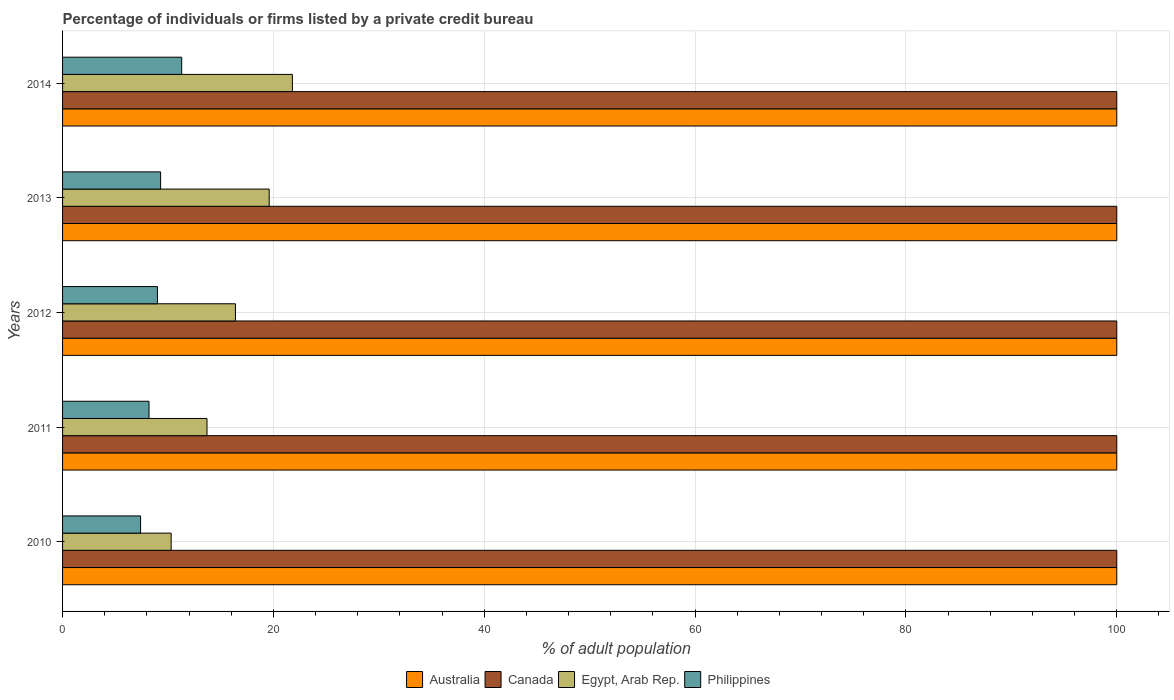How many groups of bars are there?
Offer a terse response. 5. Are the number of bars on each tick of the Y-axis equal?
Offer a terse response. Yes. How many bars are there on the 1st tick from the top?
Offer a terse response. 4. What is the label of the 5th group of bars from the top?
Keep it short and to the point. 2010. What is the percentage of population listed by a private credit bureau in Canada in 2010?
Give a very brief answer. 100. Across all years, what is the maximum percentage of population listed by a private credit bureau in Canada?
Make the answer very short. 100. What is the total percentage of population listed by a private credit bureau in Philippines in the graph?
Provide a short and direct response. 45.2. What is the difference between the percentage of population listed by a private credit bureau in Canada in 2010 and that in 2014?
Make the answer very short. 0. What is the difference between the percentage of population listed by a private credit bureau in Canada in 2011 and the percentage of population listed by a private credit bureau in Australia in 2012?
Ensure brevity in your answer.  0. In the year 2011, what is the difference between the percentage of population listed by a private credit bureau in Australia and percentage of population listed by a private credit bureau in Philippines?
Your answer should be compact. 91.8. In how many years, is the percentage of population listed by a private credit bureau in Egypt, Arab Rep. greater than 84 %?
Keep it short and to the point. 0. What is the ratio of the percentage of population listed by a private credit bureau in Philippines in 2012 to that in 2013?
Give a very brief answer. 0.97. What is the difference between the highest and the second highest percentage of population listed by a private credit bureau in Australia?
Give a very brief answer. 0. What is the difference between the highest and the lowest percentage of population listed by a private credit bureau in Egypt, Arab Rep.?
Make the answer very short. 11.5. In how many years, is the percentage of population listed by a private credit bureau in Canada greater than the average percentage of population listed by a private credit bureau in Canada taken over all years?
Provide a succinct answer. 0. Is the sum of the percentage of population listed by a private credit bureau in Australia in 2011 and 2014 greater than the maximum percentage of population listed by a private credit bureau in Egypt, Arab Rep. across all years?
Keep it short and to the point. Yes. Is it the case that in every year, the sum of the percentage of population listed by a private credit bureau in Canada and percentage of population listed by a private credit bureau in Egypt, Arab Rep. is greater than the sum of percentage of population listed by a private credit bureau in Philippines and percentage of population listed by a private credit bureau in Australia?
Offer a very short reply. Yes. What does the 3rd bar from the top in 2013 represents?
Your answer should be compact. Canada. What does the 2nd bar from the bottom in 2012 represents?
Make the answer very short. Canada. Is it the case that in every year, the sum of the percentage of population listed by a private credit bureau in Egypt, Arab Rep. and percentage of population listed by a private credit bureau in Canada is greater than the percentage of population listed by a private credit bureau in Australia?
Ensure brevity in your answer.  Yes. How many bars are there?
Keep it short and to the point. 20. Are all the bars in the graph horizontal?
Provide a succinct answer. Yes. What is the difference between two consecutive major ticks on the X-axis?
Offer a very short reply. 20. Does the graph contain grids?
Your answer should be very brief. Yes. What is the title of the graph?
Provide a succinct answer. Percentage of individuals or firms listed by a private credit bureau. What is the label or title of the X-axis?
Make the answer very short. % of adult population. What is the label or title of the Y-axis?
Keep it short and to the point. Years. What is the % of adult population of Australia in 2010?
Give a very brief answer. 100. What is the % of adult population of Canada in 2010?
Your response must be concise. 100. What is the % of adult population in Australia in 2011?
Make the answer very short. 100. What is the % of adult population of Canada in 2011?
Your answer should be very brief. 100. What is the % of adult population in Philippines in 2011?
Keep it short and to the point. 8.2. What is the % of adult population in Australia in 2012?
Keep it short and to the point. 100. What is the % of adult population in Australia in 2013?
Offer a terse response. 100. What is the % of adult population of Canada in 2013?
Offer a very short reply. 100. What is the % of adult population of Egypt, Arab Rep. in 2013?
Your answer should be compact. 19.6. What is the % of adult population in Egypt, Arab Rep. in 2014?
Your response must be concise. 21.8. Across all years, what is the maximum % of adult population in Canada?
Make the answer very short. 100. Across all years, what is the maximum % of adult population in Egypt, Arab Rep.?
Ensure brevity in your answer.  21.8. Across all years, what is the minimum % of adult population of Egypt, Arab Rep.?
Your answer should be very brief. 10.3. What is the total % of adult population of Australia in the graph?
Give a very brief answer. 500. What is the total % of adult population of Canada in the graph?
Make the answer very short. 500. What is the total % of adult population of Egypt, Arab Rep. in the graph?
Your answer should be very brief. 81.8. What is the total % of adult population of Philippines in the graph?
Make the answer very short. 45.2. What is the difference between the % of adult population of Australia in 2010 and that in 2011?
Your answer should be very brief. 0. What is the difference between the % of adult population of Australia in 2010 and that in 2012?
Provide a short and direct response. 0. What is the difference between the % of adult population of Egypt, Arab Rep. in 2010 and that in 2012?
Make the answer very short. -6.1. What is the difference between the % of adult population in Philippines in 2010 and that in 2012?
Keep it short and to the point. -1.6. What is the difference between the % of adult population of Egypt, Arab Rep. in 2010 and that in 2013?
Make the answer very short. -9.3. What is the difference between the % of adult population in Philippines in 2010 and that in 2013?
Your answer should be very brief. -1.9. What is the difference between the % of adult population in Australia in 2010 and that in 2014?
Provide a short and direct response. 0. What is the difference between the % of adult population in Australia in 2011 and that in 2012?
Your answer should be compact. 0. What is the difference between the % of adult population of Canada in 2011 and that in 2012?
Provide a short and direct response. 0. What is the difference between the % of adult population in Philippines in 2011 and that in 2012?
Ensure brevity in your answer.  -0.8. What is the difference between the % of adult population in Canada in 2011 and that in 2013?
Your answer should be compact. 0. What is the difference between the % of adult population of Egypt, Arab Rep. in 2011 and that in 2013?
Your response must be concise. -5.9. What is the difference between the % of adult population in Philippines in 2011 and that in 2013?
Your answer should be very brief. -1.1. What is the difference between the % of adult population of Australia in 2011 and that in 2014?
Give a very brief answer. 0. What is the difference between the % of adult population of Egypt, Arab Rep. in 2011 and that in 2014?
Ensure brevity in your answer.  -8.1. What is the difference between the % of adult population in Australia in 2012 and that in 2013?
Make the answer very short. 0. What is the difference between the % of adult population of Philippines in 2012 and that in 2013?
Your answer should be compact. -0.3. What is the difference between the % of adult population in Australia in 2012 and that in 2014?
Keep it short and to the point. 0. What is the difference between the % of adult population of Canada in 2012 and that in 2014?
Your answer should be compact. 0. What is the difference between the % of adult population of Egypt, Arab Rep. in 2012 and that in 2014?
Your answer should be compact. -5.4. What is the difference between the % of adult population of Egypt, Arab Rep. in 2013 and that in 2014?
Provide a succinct answer. -2.2. What is the difference between the % of adult population of Australia in 2010 and the % of adult population of Egypt, Arab Rep. in 2011?
Offer a terse response. 86.3. What is the difference between the % of adult population in Australia in 2010 and the % of adult population in Philippines in 2011?
Give a very brief answer. 91.8. What is the difference between the % of adult population of Canada in 2010 and the % of adult population of Egypt, Arab Rep. in 2011?
Your answer should be very brief. 86.3. What is the difference between the % of adult population in Canada in 2010 and the % of adult population in Philippines in 2011?
Your response must be concise. 91.8. What is the difference between the % of adult population in Australia in 2010 and the % of adult population in Canada in 2012?
Provide a succinct answer. 0. What is the difference between the % of adult population of Australia in 2010 and the % of adult population of Egypt, Arab Rep. in 2012?
Offer a very short reply. 83.6. What is the difference between the % of adult population of Australia in 2010 and the % of adult population of Philippines in 2012?
Provide a short and direct response. 91. What is the difference between the % of adult population in Canada in 2010 and the % of adult population in Egypt, Arab Rep. in 2012?
Ensure brevity in your answer.  83.6. What is the difference between the % of adult population in Canada in 2010 and the % of adult population in Philippines in 2012?
Your response must be concise. 91. What is the difference between the % of adult population of Australia in 2010 and the % of adult population of Canada in 2013?
Ensure brevity in your answer.  0. What is the difference between the % of adult population of Australia in 2010 and the % of adult population of Egypt, Arab Rep. in 2013?
Provide a succinct answer. 80.4. What is the difference between the % of adult population in Australia in 2010 and the % of adult population in Philippines in 2013?
Your answer should be compact. 90.7. What is the difference between the % of adult population of Canada in 2010 and the % of adult population of Egypt, Arab Rep. in 2013?
Keep it short and to the point. 80.4. What is the difference between the % of adult population in Canada in 2010 and the % of adult population in Philippines in 2013?
Give a very brief answer. 90.7. What is the difference between the % of adult population of Australia in 2010 and the % of adult population of Canada in 2014?
Ensure brevity in your answer.  0. What is the difference between the % of adult population of Australia in 2010 and the % of adult population of Egypt, Arab Rep. in 2014?
Provide a succinct answer. 78.2. What is the difference between the % of adult population of Australia in 2010 and the % of adult population of Philippines in 2014?
Your answer should be compact. 88.7. What is the difference between the % of adult population of Canada in 2010 and the % of adult population of Egypt, Arab Rep. in 2014?
Offer a very short reply. 78.2. What is the difference between the % of adult population of Canada in 2010 and the % of adult population of Philippines in 2014?
Your response must be concise. 88.7. What is the difference between the % of adult population in Australia in 2011 and the % of adult population in Egypt, Arab Rep. in 2012?
Ensure brevity in your answer.  83.6. What is the difference between the % of adult population of Australia in 2011 and the % of adult population of Philippines in 2012?
Ensure brevity in your answer.  91. What is the difference between the % of adult population in Canada in 2011 and the % of adult population in Egypt, Arab Rep. in 2012?
Keep it short and to the point. 83.6. What is the difference between the % of adult population of Canada in 2011 and the % of adult population of Philippines in 2012?
Ensure brevity in your answer.  91. What is the difference between the % of adult population in Australia in 2011 and the % of adult population in Canada in 2013?
Provide a short and direct response. 0. What is the difference between the % of adult population of Australia in 2011 and the % of adult population of Egypt, Arab Rep. in 2013?
Make the answer very short. 80.4. What is the difference between the % of adult population in Australia in 2011 and the % of adult population in Philippines in 2013?
Keep it short and to the point. 90.7. What is the difference between the % of adult population of Canada in 2011 and the % of adult population of Egypt, Arab Rep. in 2013?
Make the answer very short. 80.4. What is the difference between the % of adult population of Canada in 2011 and the % of adult population of Philippines in 2013?
Ensure brevity in your answer.  90.7. What is the difference between the % of adult population in Australia in 2011 and the % of adult population in Canada in 2014?
Make the answer very short. 0. What is the difference between the % of adult population of Australia in 2011 and the % of adult population of Egypt, Arab Rep. in 2014?
Your answer should be very brief. 78.2. What is the difference between the % of adult population of Australia in 2011 and the % of adult population of Philippines in 2014?
Offer a terse response. 88.7. What is the difference between the % of adult population in Canada in 2011 and the % of adult population in Egypt, Arab Rep. in 2014?
Give a very brief answer. 78.2. What is the difference between the % of adult population of Canada in 2011 and the % of adult population of Philippines in 2014?
Ensure brevity in your answer.  88.7. What is the difference between the % of adult population in Egypt, Arab Rep. in 2011 and the % of adult population in Philippines in 2014?
Ensure brevity in your answer.  2.4. What is the difference between the % of adult population in Australia in 2012 and the % of adult population in Canada in 2013?
Make the answer very short. 0. What is the difference between the % of adult population of Australia in 2012 and the % of adult population of Egypt, Arab Rep. in 2013?
Your response must be concise. 80.4. What is the difference between the % of adult population in Australia in 2012 and the % of adult population in Philippines in 2013?
Make the answer very short. 90.7. What is the difference between the % of adult population of Canada in 2012 and the % of adult population of Egypt, Arab Rep. in 2013?
Your response must be concise. 80.4. What is the difference between the % of adult population in Canada in 2012 and the % of adult population in Philippines in 2013?
Offer a terse response. 90.7. What is the difference between the % of adult population in Egypt, Arab Rep. in 2012 and the % of adult population in Philippines in 2013?
Keep it short and to the point. 7.1. What is the difference between the % of adult population in Australia in 2012 and the % of adult population in Canada in 2014?
Ensure brevity in your answer.  0. What is the difference between the % of adult population of Australia in 2012 and the % of adult population of Egypt, Arab Rep. in 2014?
Provide a short and direct response. 78.2. What is the difference between the % of adult population of Australia in 2012 and the % of adult population of Philippines in 2014?
Keep it short and to the point. 88.7. What is the difference between the % of adult population in Canada in 2012 and the % of adult population in Egypt, Arab Rep. in 2014?
Provide a short and direct response. 78.2. What is the difference between the % of adult population of Canada in 2012 and the % of adult population of Philippines in 2014?
Your answer should be compact. 88.7. What is the difference between the % of adult population in Egypt, Arab Rep. in 2012 and the % of adult population in Philippines in 2014?
Give a very brief answer. 5.1. What is the difference between the % of adult population of Australia in 2013 and the % of adult population of Egypt, Arab Rep. in 2014?
Your response must be concise. 78.2. What is the difference between the % of adult population of Australia in 2013 and the % of adult population of Philippines in 2014?
Your response must be concise. 88.7. What is the difference between the % of adult population of Canada in 2013 and the % of adult population of Egypt, Arab Rep. in 2014?
Your answer should be very brief. 78.2. What is the difference between the % of adult population of Canada in 2013 and the % of adult population of Philippines in 2014?
Keep it short and to the point. 88.7. What is the average % of adult population in Canada per year?
Provide a succinct answer. 100. What is the average % of adult population of Egypt, Arab Rep. per year?
Give a very brief answer. 16.36. What is the average % of adult population of Philippines per year?
Provide a short and direct response. 9.04. In the year 2010, what is the difference between the % of adult population of Australia and % of adult population of Canada?
Ensure brevity in your answer.  0. In the year 2010, what is the difference between the % of adult population of Australia and % of adult population of Egypt, Arab Rep.?
Provide a short and direct response. 89.7. In the year 2010, what is the difference between the % of adult population in Australia and % of adult population in Philippines?
Offer a terse response. 92.6. In the year 2010, what is the difference between the % of adult population in Canada and % of adult population in Egypt, Arab Rep.?
Your answer should be compact. 89.7. In the year 2010, what is the difference between the % of adult population in Canada and % of adult population in Philippines?
Offer a terse response. 92.6. In the year 2010, what is the difference between the % of adult population of Egypt, Arab Rep. and % of adult population of Philippines?
Offer a very short reply. 2.9. In the year 2011, what is the difference between the % of adult population of Australia and % of adult population of Canada?
Ensure brevity in your answer.  0. In the year 2011, what is the difference between the % of adult population of Australia and % of adult population of Egypt, Arab Rep.?
Ensure brevity in your answer.  86.3. In the year 2011, what is the difference between the % of adult population in Australia and % of adult population in Philippines?
Keep it short and to the point. 91.8. In the year 2011, what is the difference between the % of adult population in Canada and % of adult population in Egypt, Arab Rep.?
Keep it short and to the point. 86.3. In the year 2011, what is the difference between the % of adult population of Canada and % of adult population of Philippines?
Your answer should be compact. 91.8. In the year 2012, what is the difference between the % of adult population of Australia and % of adult population of Canada?
Your answer should be very brief. 0. In the year 2012, what is the difference between the % of adult population in Australia and % of adult population in Egypt, Arab Rep.?
Your response must be concise. 83.6. In the year 2012, what is the difference between the % of adult population in Australia and % of adult population in Philippines?
Keep it short and to the point. 91. In the year 2012, what is the difference between the % of adult population in Canada and % of adult population in Egypt, Arab Rep.?
Give a very brief answer. 83.6. In the year 2012, what is the difference between the % of adult population in Canada and % of adult population in Philippines?
Your answer should be very brief. 91. In the year 2012, what is the difference between the % of adult population of Egypt, Arab Rep. and % of adult population of Philippines?
Offer a terse response. 7.4. In the year 2013, what is the difference between the % of adult population in Australia and % of adult population in Canada?
Give a very brief answer. 0. In the year 2013, what is the difference between the % of adult population in Australia and % of adult population in Egypt, Arab Rep.?
Your answer should be very brief. 80.4. In the year 2013, what is the difference between the % of adult population of Australia and % of adult population of Philippines?
Provide a short and direct response. 90.7. In the year 2013, what is the difference between the % of adult population of Canada and % of adult population of Egypt, Arab Rep.?
Keep it short and to the point. 80.4. In the year 2013, what is the difference between the % of adult population of Canada and % of adult population of Philippines?
Your response must be concise. 90.7. In the year 2014, what is the difference between the % of adult population in Australia and % of adult population in Egypt, Arab Rep.?
Your answer should be very brief. 78.2. In the year 2014, what is the difference between the % of adult population in Australia and % of adult population in Philippines?
Your answer should be very brief. 88.7. In the year 2014, what is the difference between the % of adult population in Canada and % of adult population in Egypt, Arab Rep.?
Ensure brevity in your answer.  78.2. In the year 2014, what is the difference between the % of adult population in Canada and % of adult population in Philippines?
Offer a terse response. 88.7. What is the ratio of the % of adult population in Australia in 2010 to that in 2011?
Make the answer very short. 1. What is the ratio of the % of adult population of Canada in 2010 to that in 2011?
Your response must be concise. 1. What is the ratio of the % of adult population of Egypt, Arab Rep. in 2010 to that in 2011?
Give a very brief answer. 0.75. What is the ratio of the % of adult population of Philippines in 2010 to that in 2011?
Ensure brevity in your answer.  0.9. What is the ratio of the % of adult population of Egypt, Arab Rep. in 2010 to that in 2012?
Offer a terse response. 0.63. What is the ratio of the % of adult population in Philippines in 2010 to that in 2012?
Give a very brief answer. 0.82. What is the ratio of the % of adult population in Canada in 2010 to that in 2013?
Offer a very short reply. 1. What is the ratio of the % of adult population of Egypt, Arab Rep. in 2010 to that in 2013?
Ensure brevity in your answer.  0.53. What is the ratio of the % of adult population in Philippines in 2010 to that in 2013?
Your answer should be very brief. 0.8. What is the ratio of the % of adult population in Egypt, Arab Rep. in 2010 to that in 2014?
Ensure brevity in your answer.  0.47. What is the ratio of the % of adult population of Philippines in 2010 to that in 2014?
Keep it short and to the point. 0.65. What is the ratio of the % of adult population of Australia in 2011 to that in 2012?
Keep it short and to the point. 1. What is the ratio of the % of adult population in Canada in 2011 to that in 2012?
Offer a terse response. 1. What is the ratio of the % of adult population in Egypt, Arab Rep. in 2011 to that in 2012?
Offer a very short reply. 0.84. What is the ratio of the % of adult population in Philippines in 2011 to that in 2012?
Your answer should be very brief. 0.91. What is the ratio of the % of adult population of Canada in 2011 to that in 2013?
Ensure brevity in your answer.  1. What is the ratio of the % of adult population in Egypt, Arab Rep. in 2011 to that in 2013?
Provide a short and direct response. 0.7. What is the ratio of the % of adult population in Philippines in 2011 to that in 2013?
Provide a succinct answer. 0.88. What is the ratio of the % of adult population of Egypt, Arab Rep. in 2011 to that in 2014?
Provide a short and direct response. 0.63. What is the ratio of the % of adult population of Philippines in 2011 to that in 2014?
Make the answer very short. 0.73. What is the ratio of the % of adult population of Australia in 2012 to that in 2013?
Offer a very short reply. 1. What is the ratio of the % of adult population of Egypt, Arab Rep. in 2012 to that in 2013?
Your response must be concise. 0.84. What is the ratio of the % of adult population of Philippines in 2012 to that in 2013?
Provide a succinct answer. 0.97. What is the ratio of the % of adult population of Egypt, Arab Rep. in 2012 to that in 2014?
Provide a short and direct response. 0.75. What is the ratio of the % of adult population in Philippines in 2012 to that in 2014?
Offer a very short reply. 0.8. What is the ratio of the % of adult population of Australia in 2013 to that in 2014?
Offer a terse response. 1. What is the ratio of the % of adult population in Canada in 2013 to that in 2014?
Offer a terse response. 1. What is the ratio of the % of adult population of Egypt, Arab Rep. in 2013 to that in 2014?
Give a very brief answer. 0.9. What is the ratio of the % of adult population in Philippines in 2013 to that in 2014?
Your response must be concise. 0.82. What is the difference between the highest and the second highest % of adult population in Australia?
Provide a short and direct response. 0. What is the difference between the highest and the second highest % of adult population of Canada?
Your response must be concise. 0. What is the difference between the highest and the lowest % of adult population in Australia?
Ensure brevity in your answer.  0. What is the difference between the highest and the lowest % of adult population of Canada?
Your answer should be compact. 0. What is the difference between the highest and the lowest % of adult population in Philippines?
Keep it short and to the point. 3.9. 